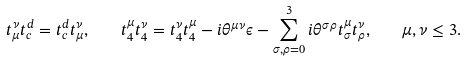<formula> <loc_0><loc_0><loc_500><loc_500>t ^ { \nu } _ { \mu } t _ { c } ^ { d } = t _ { c } ^ { d } t ^ { \nu } _ { \mu } , \quad t _ { 4 } ^ { \mu } t _ { 4 } ^ { \nu } = t _ { 4 } ^ { \nu } t _ { 4 } ^ { \mu } - i \theta ^ { \mu \nu } \epsilon - \sum _ { \sigma , \rho = 0 } ^ { 3 } i \theta ^ { \sigma \rho } t _ { \sigma } ^ { \mu } t _ { \rho } ^ { \nu } , \quad \mu , \nu \leq 3 .</formula> 